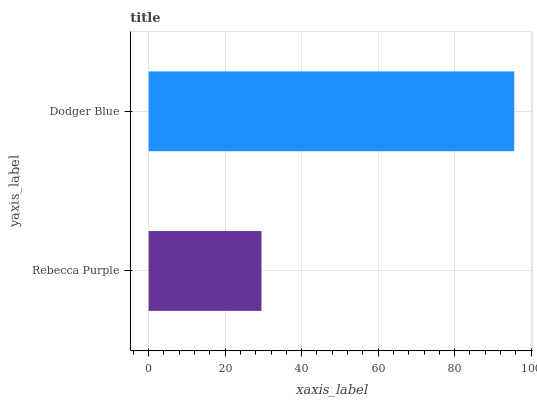Is Rebecca Purple the minimum?
Answer yes or no. Yes. Is Dodger Blue the maximum?
Answer yes or no. Yes. Is Dodger Blue the minimum?
Answer yes or no. No. Is Dodger Blue greater than Rebecca Purple?
Answer yes or no. Yes. Is Rebecca Purple less than Dodger Blue?
Answer yes or no. Yes. Is Rebecca Purple greater than Dodger Blue?
Answer yes or no. No. Is Dodger Blue less than Rebecca Purple?
Answer yes or no. No. Is Dodger Blue the high median?
Answer yes or no. Yes. Is Rebecca Purple the low median?
Answer yes or no. Yes. Is Rebecca Purple the high median?
Answer yes or no. No. Is Dodger Blue the low median?
Answer yes or no. No. 